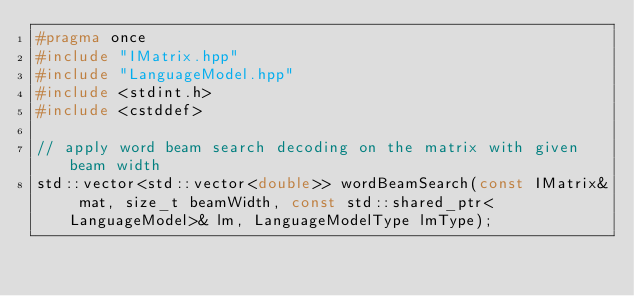<code> <loc_0><loc_0><loc_500><loc_500><_C++_>#pragma once
#include "IMatrix.hpp"
#include "LanguageModel.hpp"
#include <stdint.h>
#include <cstddef>

// apply word beam search decoding on the matrix with given beam width
std::vector<std::vector<double>> wordBeamSearch(const IMatrix& mat, size_t beamWidth, const std::shared_ptr<LanguageModel>& lm, LanguageModelType lmType);

</code> 